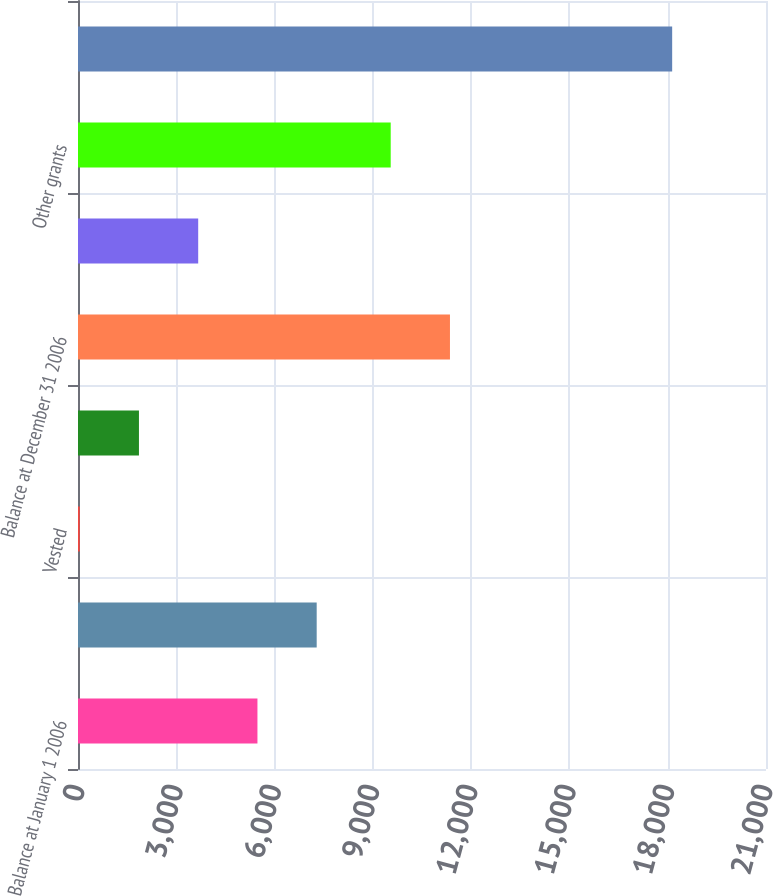Convert chart. <chart><loc_0><loc_0><loc_500><loc_500><bar_chart><fcel>Balance at January 1 2006<fcel>Granted<fcel>Vested<fcel>Forfeited<fcel>Balance at December 31 2006<fcel>Option exchange grants<fcel>Other grants<fcel>Balance at December 31 2007<nl><fcel>5477.2<fcel>7285.6<fcel>52<fcel>1860.4<fcel>11353.4<fcel>3668.8<fcel>9545<fcel>18136<nl></chart> 